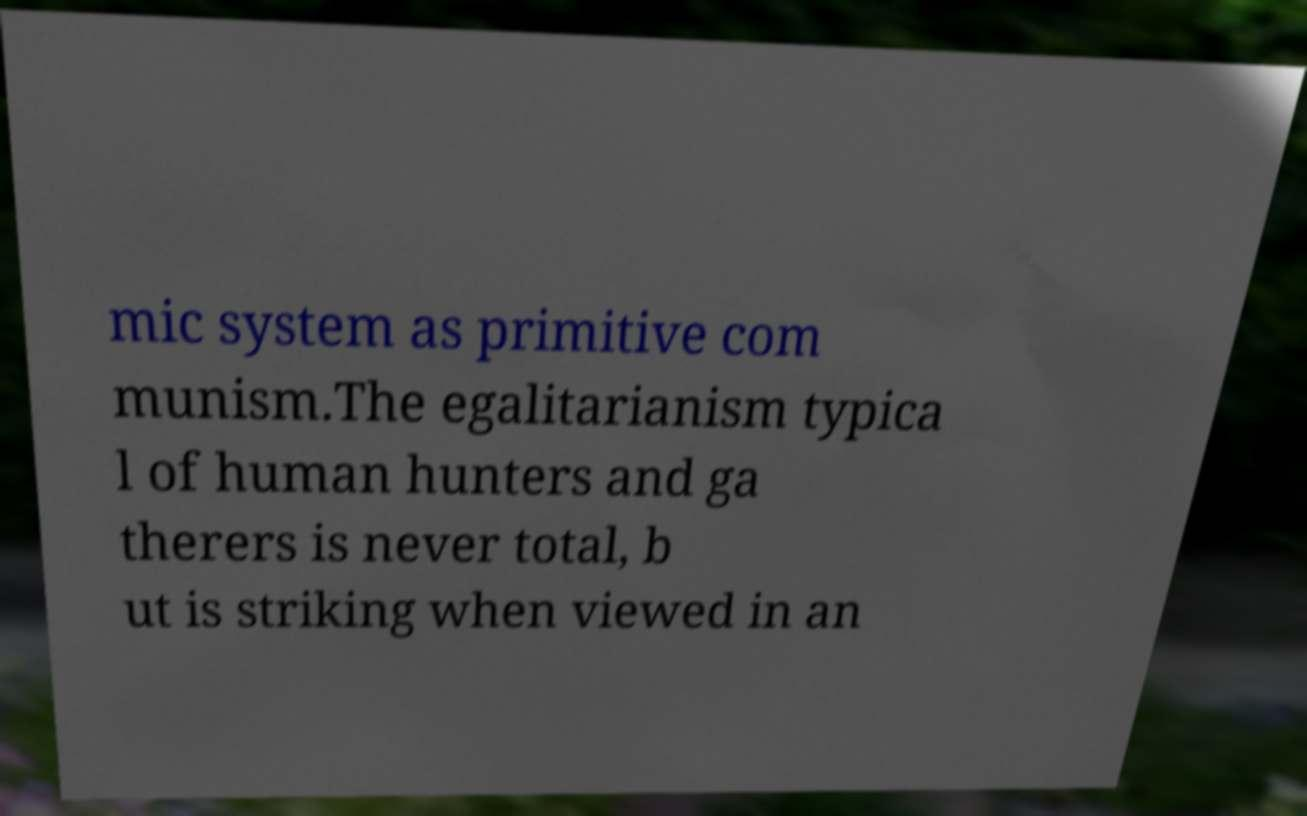Could you assist in decoding the text presented in this image and type it out clearly? mic system as primitive com munism.The egalitarianism typica l of human hunters and ga therers is never total, b ut is striking when viewed in an 